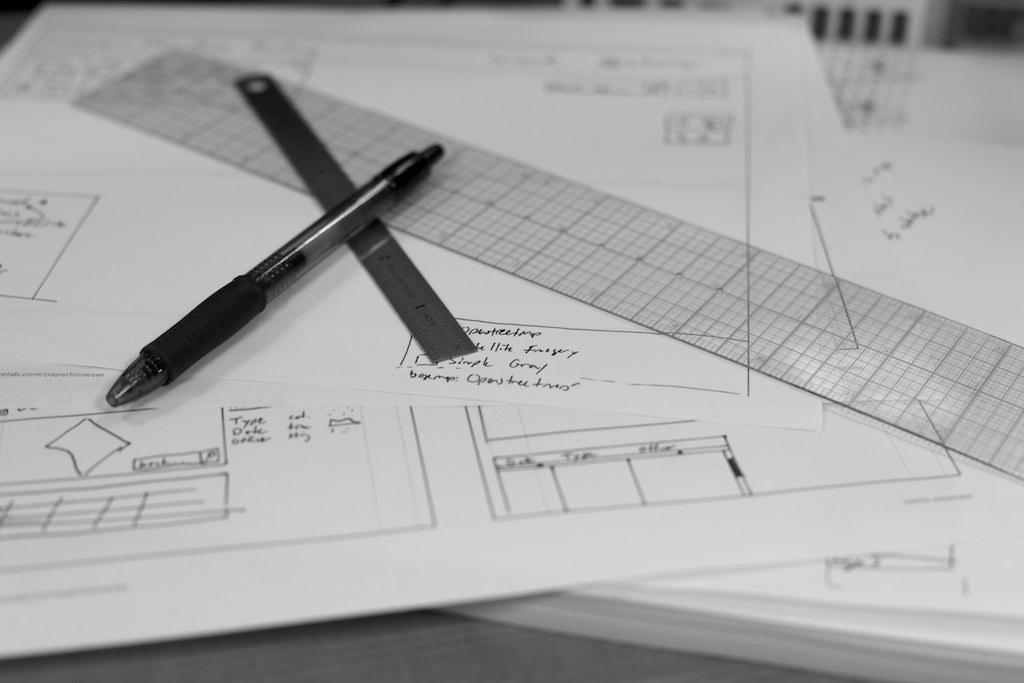What is the color scheme of the image? The image is black and white. What piece of furniture is present in the image? There is a table in the image. What items are on the table? There are papers, a pen, and a scale on the table. How far away is the hand holding the can from the table in the image? There is no hand or can present in the image, so it is not possible to determine the distance between them. 